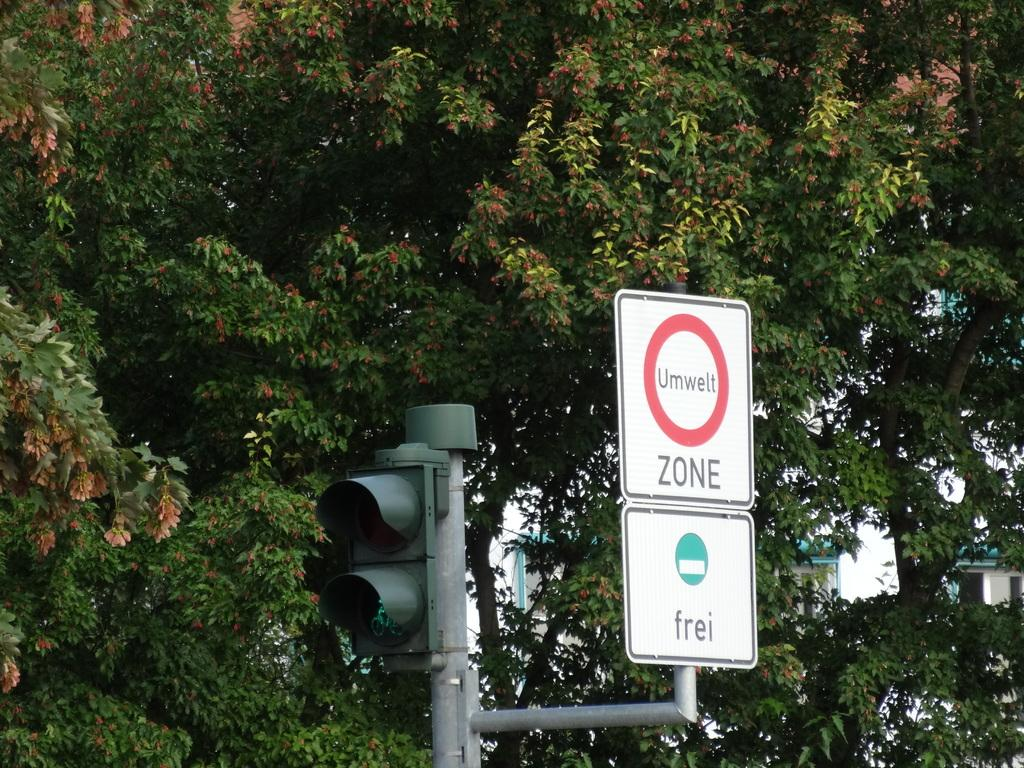<image>
Create a compact narrative representing the image presented. A sign for ZONE sits next to a stoplight 